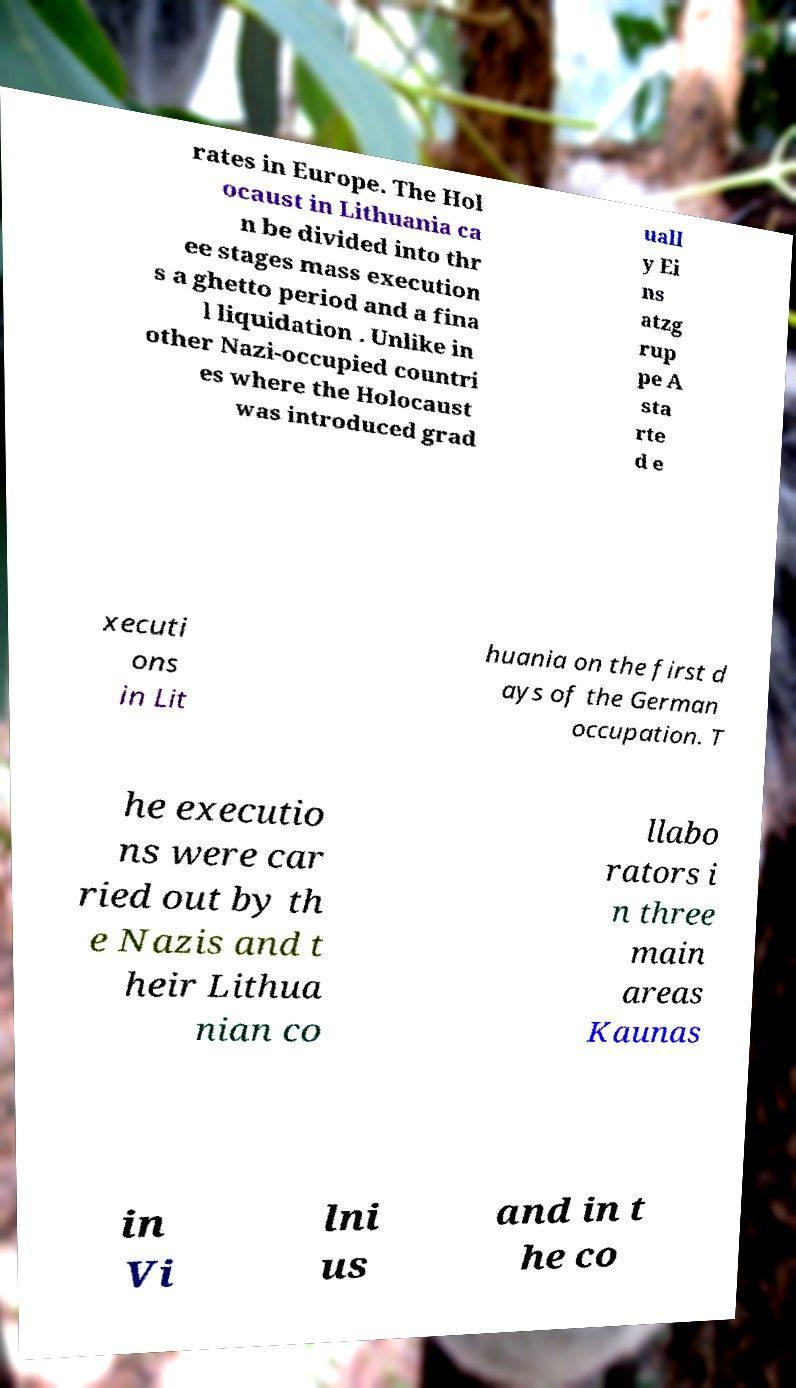There's text embedded in this image that I need extracted. Can you transcribe it verbatim? rates in Europe. The Hol ocaust in Lithuania ca n be divided into thr ee stages mass execution s a ghetto period and a fina l liquidation . Unlike in other Nazi-occupied countri es where the Holocaust was introduced grad uall y Ei ns atzg rup pe A sta rte d e xecuti ons in Lit huania on the first d ays of the German occupation. T he executio ns were car ried out by th e Nazis and t heir Lithua nian co llabo rators i n three main areas Kaunas in Vi lni us and in t he co 